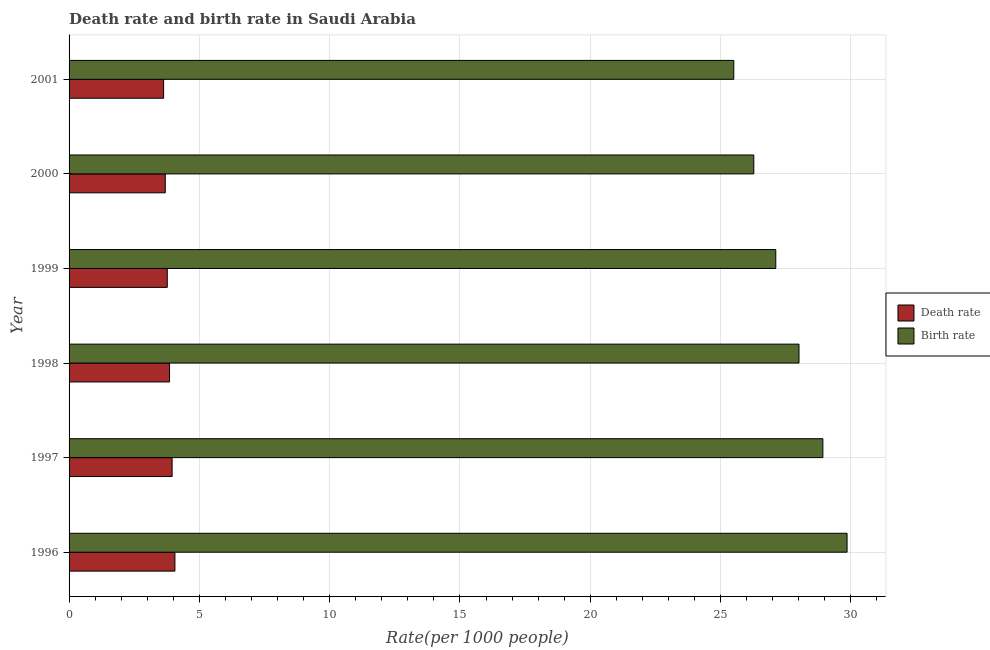How many different coloured bars are there?
Keep it short and to the point. 2. How many groups of bars are there?
Give a very brief answer. 6. Are the number of bars per tick equal to the number of legend labels?
Your answer should be very brief. Yes. Are the number of bars on each tick of the Y-axis equal?
Ensure brevity in your answer.  Yes. How many bars are there on the 2nd tick from the bottom?
Offer a terse response. 2. What is the death rate in 1998?
Make the answer very short. 3.85. Across all years, what is the maximum birth rate?
Give a very brief answer. 29.85. Across all years, what is the minimum birth rate?
Your answer should be very brief. 25.51. In which year was the birth rate minimum?
Your answer should be very brief. 2001. What is the total death rate in the graph?
Offer a very short reply. 22.96. What is the difference between the death rate in 1998 and that in 2001?
Keep it short and to the point. 0.23. What is the difference between the death rate in 1999 and the birth rate in 2000?
Give a very brief answer. -22.51. What is the average death rate per year?
Make the answer very short. 3.83. In the year 2000, what is the difference between the death rate and birth rate?
Offer a very short reply. -22.58. In how many years, is the death rate greater than 20 ?
Offer a very short reply. 0. What is the ratio of the death rate in 1999 to that in 2000?
Make the answer very short. 1.02. Is the death rate in 1997 less than that in 2001?
Your answer should be very brief. No. What is the difference between the highest and the second highest birth rate?
Give a very brief answer. 0.93. What is the difference between the highest and the lowest death rate?
Provide a succinct answer. 0.43. What does the 2nd bar from the top in 2001 represents?
Provide a succinct answer. Death rate. What does the 1st bar from the bottom in 1997 represents?
Make the answer very short. Death rate. How many years are there in the graph?
Ensure brevity in your answer.  6. Are the values on the major ticks of X-axis written in scientific E-notation?
Keep it short and to the point. No. How are the legend labels stacked?
Make the answer very short. Vertical. What is the title of the graph?
Keep it short and to the point. Death rate and birth rate in Saudi Arabia. Does "Under five" appear as one of the legend labels in the graph?
Ensure brevity in your answer.  No. What is the label or title of the X-axis?
Give a very brief answer. Rate(per 1000 people). What is the label or title of the Y-axis?
Ensure brevity in your answer.  Year. What is the Rate(per 1000 people) in Death rate in 1996?
Ensure brevity in your answer.  4.06. What is the Rate(per 1000 people) in Birth rate in 1996?
Give a very brief answer. 29.85. What is the Rate(per 1000 people) in Death rate in 1997?
Offer a very short reply. 3.95. What is the Rate(per 1000 people) of Birth rate in 1997?
Keep it short and to the point. 28.93. What is the Rate(per 1000 people) of Death rate in 1998?
Keep it short and to the point. 3.85. What is the Rate(per 1000 people) in Birth rate in 1998?
Give a very brief answer. 28.01. What is the Rate(per 1000 people) in Death rate in 1999?
Give a very brief answer. 3.77. What is the Rate(per 1000 people) in Birth rate in 1999?
Make the answer very short. 27.12. What is the Rate(per 1000 people) of Death rate in 2000?
Offer a very short reply. 3.69. What is the Rate(per 1000 people) in Birth rate in 2000?
Provide a succinct answer. 26.27. What is the Rate(per 1000 people) in Death rate in 2001?
Ensure brevity in your answer.  3.63. What is the Rate(per 1000 people) in Birth rate in 2001?
Your response must be concise. 25.51. Across all years, what is the maximum Rate(per 1000 people) in Death rate?
Provide a succinct answer. 4.06. Across all years, what is the maximum Rate(per 1000 people) in Birth rate?
Offer a very short reply. 29.85. Across all years, what is the minimum Rate(per 1000 people) of Death rate?
Your answer should be very brief. 3.63. Across all years, what is the minimum Rate(per 1000 people) of Birth rate?
Keep it short and to the point. 25.51. What is the total Rate(per 1000 people) in Death rate in the graph?
Offer a very short reply. 22.96. What is the total Rate(per 1000 people) in Birth rate in the graph?
Keep it short and to the point. 165.69. What is the difference between the Rate(per 1000 people) in Death rate in 1996 and that in 1997?
Provide a succinct answer. 0.11. What is the difference between the Rate(per 1000 people) of Birth rate in 1996 and that in 1997?
Provide a short and direct response. 0.93. What is the difference between the Rate(per 1000 people) in Death rate in 1996 and that in 1998?
Your answer should be very brief. 0.21. What is the difference between the Rate(per 1000 people) in Birth rate in 1996 and that in 1998?
Your answer should be very brief. 1.84. What is the difference between the Rate(per 1000 people) in Death rate in 1996 and that in 1999?
Provide a short and direct response. 0.29. What is the difference between the Rate(per 1000 people) in Birth rate in 1996 and that in 1999?
Your answer should be very brief. 2.73. What is the difference between the Rate(per 1000 people) of Death rate in 1996 and that in 2000?
Ensure brevity in your answer.  0.37. What is the difference between the Rate(per 1000 people) of Birth rate in 1996 and that in 2000?
Offer a very short reply. 3.58. What is the difference between the Rate(per 1000 people) in Death rate in 1996 and that in 2001?
Keep it short and to the point. 0.43. What is the difference between the Rate(per 1000 people) of Birth rate in 1996 and that in 2001?
Keep it short and to the point. 4.35. What is the difference between the Rate(per 1000 people) in Death rate in 1997 and that in 1998?
Give a very brief answer. 0.1. What is the difference between the Rate(per 1000 people) of Birth rate in 1997 and that in 1998?
Give a very brief answer. 0.92. What is the difference between the Rate(per 1000 people) in Death rate in 1997 and that in 1999?
Offer a terse response. 0.19. What is the difference between the Rate(per 1000 people) of Birth rate in 1997 and that in 1999?
Your response must be concise. 1.81. What is the difference between the Rate(per 1000 people) of Death rate in 1997 and that in 2000?
Keep it short and to the point. 0.26. What is the difference between the Rate(per 1000 people) in Birth rate in 1997 and that in 2000?
Make the answer very short. 2.65. What is the difference between the Rate(per 1000 people) of Death rate in 1997 and that in 2001?
Your response must be concise. 0.33. What is the difference between the Rate(per 1000 people) of Birth rate in 1997 and that in 2001?
Offer a terse response. 3.42. What is the difference between the Rate(per 1000 people) of Death rate in 1998 and that in 1999?
Your answer should be compact. 0.09. What is the difference between the Rate(per 1000 people) in Birth rate in 1998 and that in 1999?
Make the answer very short. 0.89. What is the difference between the Rate(per 1000 people) in Death rate in 1998 and that in 2000?
Keep it short and to the point. 0.16. What is the difference between the Rate(per 1000 people) in Birth rate in 1998 and that in 2000?
Your answer should be very brief. 1.73. What is the difference between the Rate(per 1000 people) in Death rate in 1998 and that in 2001?
Provide a succinct answer. 0.23. What is the difference between the Rate(per 1000 people) of Birth rate in 1998 and that in 2001?
Your response must be concise. 2.5. What is the difference between the Rate(per 1000 people) in Death rate in 1999 and that in 2000?
Give a very brief answer. 0.08. What is the difference between the Rate(per 1000 people) of Birth rate in 1999 and that in 2000?
Provide a succinct answer. 0.84. What is the difference between the Rate(per 1000 people) of Death rate in 1999 and that in 2001?
Your answer should be very brief. 0.14. What is the difference between the Rate(per 1000 people) of Birth rate in 1999 and that in 2001?
Provide a short and direct response. 1.61. What is the difference between the Rate(per 1000 people) of Death rate in 2000 and that in 2001?
Your answer should be very brief. 0.06. What is the difference between the Rate(per 1000 people) of Birth rate in 2000 and that in 2001?
Provide a succinct answer. 0.77. What is the difference between the Rate(per 1000 people) of Death rate in 1996 and the Rate(per 1000 people) of Birth rate in 1997?
Provide a short and direct response. -24.86. What is the difference between the Rate(per 1000 people) of Death rate in 1996 and the Rate(per 1000 people) of Birth rate in 1998?
Provide a succinct answer. -23.95. What is the difference between the Rate(per 1000 people) in Death rate in 1996 and the Rate(per 1000 people) in Birth rate in 1999?
Offer a terse response. -23.06. What is the difference between the Rate(per 1000 people) in Death rate in 1996 and the Rate(per 1000 people) in Birth rate in 2000?
Offer a very short reply. -22.21. What is the difference between the Rate(per 1000 people) of Death rate in 1996 and the Rate(per 1000 people) of Birth rate in 2001?
Your response must be concise. -21.45. What is the difference between the Rate(per 1000 people) of Death rate in 1997 and the Rate(per 1000 people) of Birth rate in 1998?
Give a very brief answer. -24.05. What is the difference between the Rate(per 1000 people) of Death rate in 1997 and the Rate(per 1000 people) of Birth rate in 1999?
Your answer should be very brief. -23.16. What is the difference between the Rate(per 1000 people) in Death rate in 1997 and the Rate(per 1000 people) in Birth rate in 2000?
Your response must be concise. -22.32. What is the difference between the Rate(per 1000 people) in Death rate in 1997 and the Rate(per 1000 people) in Birth rate in 2001?
Your answer should be compact. -21.55. What is the difference between the Rate(per 1000 people) in Death rate in 1998 and the Rate(per 1000 people) in Birth rate in 1999?
Offer a very short reply. -23.26. What is the difference between the Rate(per 1000 people) of Death rate in 1998 and the Rate(per 1000 people) of Birth rate in 2000?
Offer a very short reply. -22.42. What is the difference between the Rate(per 1000 people) of Death rate in 1998 and the Rate(per 1000 people) of Birth rate in 2001?
Your answer should be compact. -21.65. What is the difference between the Rate(per 1000 people) of Death rate in 1999 and the Rate(per 1000 people) of Birth rate in 2000?
Give a very brief answer. -22.51. What is the difference between the Rate(per 1000 people) of Death rate in 1999 and the Rate(per 1000 people) of Birth rate in 2001?
Your response must be concise. -21.74. What is the difference between the Rate(per 1000 people) of Death rate in 2000 and the Rate(per 1000 people) of Birth rate in 2001?
Keep it short and to the point. -21.82. What is the average Rate(per 1000 people) of Death rate per year?
Your response must be concise. 3.83. What is the average Rate(per 1000 people) of Birth rate per year?
Provide a short and direct response. 27.61. In the year 1996, what is the difference between the Rate(per 1000 people) in Death rate and Rate(per 1000 people) in Birth rate?
Provide a short and direct response. -25.79. In the year 1997, what is the difference between the Rate(per 1000 people) of Death rate and Rate(per 1000 people) of Birth rate?
Your answer should be very brief. -24.97. In the year 1998, what is the difference between the Rate(per 1000 people) in Death rate and Rate(per 1000 people) in Birth rate?
Your answer should be compact. -24.15. In the year 1999, what is the difference between the Rate(per 1000 people) in Death rate and Rate(per 1000 people) in Birth rate?
Offer a very short reply. -23.35. In the year 2000, what is the difference between the Rate(per 1000 people) of Death rate and Rate(per 1000 people) of Birth rate?
Give a very brief answer. -22.58. In the year 2001, what is the difference between the Rate(per 1000 people) of Death rate and Rate(per 1000 people) of Birth rate?
Make the answer very short. -21.88. What is the ratio of the Rate(per 1000 people) of Death rate in 1996 to that in 1997?
Keep it short and to the point. 1.03. What is the ratio of the Rate(per 1000 people) of Birth rate in 1996 to that in 1997?
Ensure brevity in your answer.  1.03. What is the ratio of the Rate(per 1000 people) in Death rate in 1996 to that in 1998?
Give a very brief answer. 1.05. What is the ratio of the Rate(per 1000 people) in Birth rate in 1996 to that in 1998?
Give a very brief answer. 1.07. What is the ratio of the Rate(per 1000 people) in Death rate in 1996 to that in 1999?
Ensure brevity in your answer.  1.08. What is the ratio of the Rate(per 1000 people) in Birth rate in 1996 to that in 1999?
Ensure brevity in your answer.  1.1. What is the ratio of the Rate(per 1000 people) in Death rate in 1996 to that in 2000?
Keep it short and to the point. 1.1. What is the ratio of the Rate(per 1000 people) in Birth rate in 1996 to that in 2000?
Your answer should be compact. 1.14. What is the ratio of the Rate(per 1000 people) of Death rate in 1996 to that in 2001?
Your response must be concise. 1.12. What is the ratio of the Rate(per 1000 people) of Birth rate in 1996 to that in 2001?
Your answer should be very brief. 1.17. What is the ratio of the Rate(per 1000 people) in Death rate in 1997 to that in 1998?
Ensure brevity in your answer.  1.03. What is the ratio of the Rate(per 1000 people) of Birth rate in 1997 to that in 1998?
Give a very brief answer. 1.03. What is the ratio of the Rate(per 1000 people) of Death rate in 1997 to that in 1999?
Your answer should be compact. 1.05. What is the ratio of the Rate(per 1000 people) of Birth rate in 1997 to that in 1999?
Offer a terse response. 1.07. What is the ratio of the Rate(per 1000 people) of Death rate in 1997 to that in 2000?
Your response must be concise. 1.07. What is the ratio of the Rate(per 1000 people) in Birth rate in 1997 to that in 2000?
Offer a terse response. 1.1. What is the ratio of the Rate(per 1000 people) of Death rate in 1997 to that in 2001?
Ensure brevity in your answer.  1.09. What is the ratio of the Rate(per 1000 people) in Birth rate in 1997 to that in 2001?
Your response must be concise. 1.13. What is the ratio of the Rate(per 1000 people) in Death rate in 1998 to that in 1999?
Offer a very short reply. 1.02. What is the ratio of the Rate(per 1000 people) of Birth rate in 1998 to that in 1999?
Your answer should be compact. 1.03. What is the ratio of the Rate(per 1000 people) in Death rate in 1998 to that in 2000?
Your answer should be very brief. 1.04. What is the ratio of the Rate(per 1000 people) of Birth rate in 1998 to that in 2000?
Your answer should be very brief. 1.07. What is the ratio of the Rate(per 1000 people) in Death rate in 1998 to that in 2001?
Offer a terse response. 1.06. What is the ratio of the Rate(per 1000 people) of Birth rate in 1998 to that in 2001?
Provide a short and direct response. 1.1. What is the ratio of the Rate(per 1000 people) of Death rate in 1999 to that in 2000?
Make the answer very short. 1.02. What is the ratio of the Rate(per 1000 people) in Birth rate in 1999 to that in 2000?
Keep it short and to the point. 1.03. What is the ratio of the Rate(per 1000 people) of Death rate in 1999 to that in 2001?
Your answer should be compact. 1.04. What is the ratio of the Rate(per 1000 people) of Birth rate in 1999 to that in 2001?
Your response must be concise. 1.06. What is the ratio of the Rate(per 1000 people) of Death rate in 2000 to that in 2001?
Provide a succinct answer. 1.02. What is the ratio of the Rate(per 1000 people) in Birth rate in 2000 to that in 2001?
Keep it short and to the point. 1.03. What is the difference between the highest and the second highest Rate(per 1000 people) in Death rate?
Make the answer very short. 0.11. What is the difference between the highest and the second highest Rate(per 1000 people) in Birth rate?
Your answer should be compact. 0.93. What is the difference between the highest and the lowest Rate(per 1000 people) of Death rate?
Ensure brevity in your answer.  0.43. What is the difference between the highest and the lowest Rate(per 1000 people) in Birth rate?
Give a very brief answer. 4.35. 